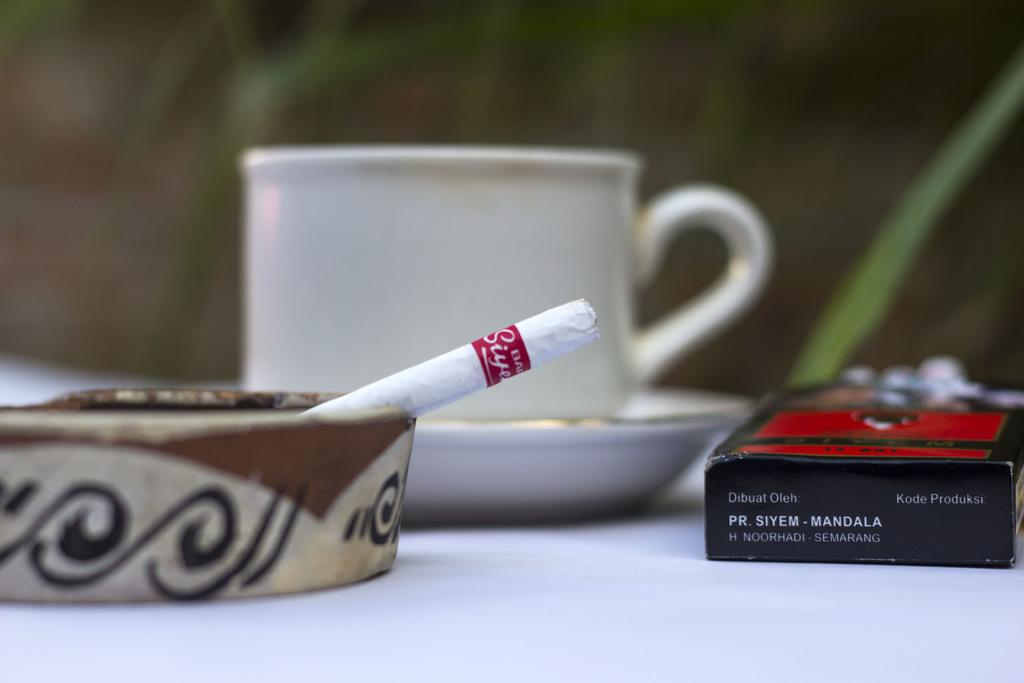What is located in the center of the image? There is a cup, a saucer, a cigarette box, a tray, and a cigarette in the center of the image. What is the purpose of the tray in the image? The tray is likely used to hold and organize the other items in the center of the image. What can be seen in the background of the image? There are plants in the background of the image. What is the surface on which the items in the center of the image are placed? There is a table at the bottom of the image. What type of ink can be seen spilling from the cigarette box in the image? There is no ink present in the image, and the cigarette box is not depicted as spilling anything. 